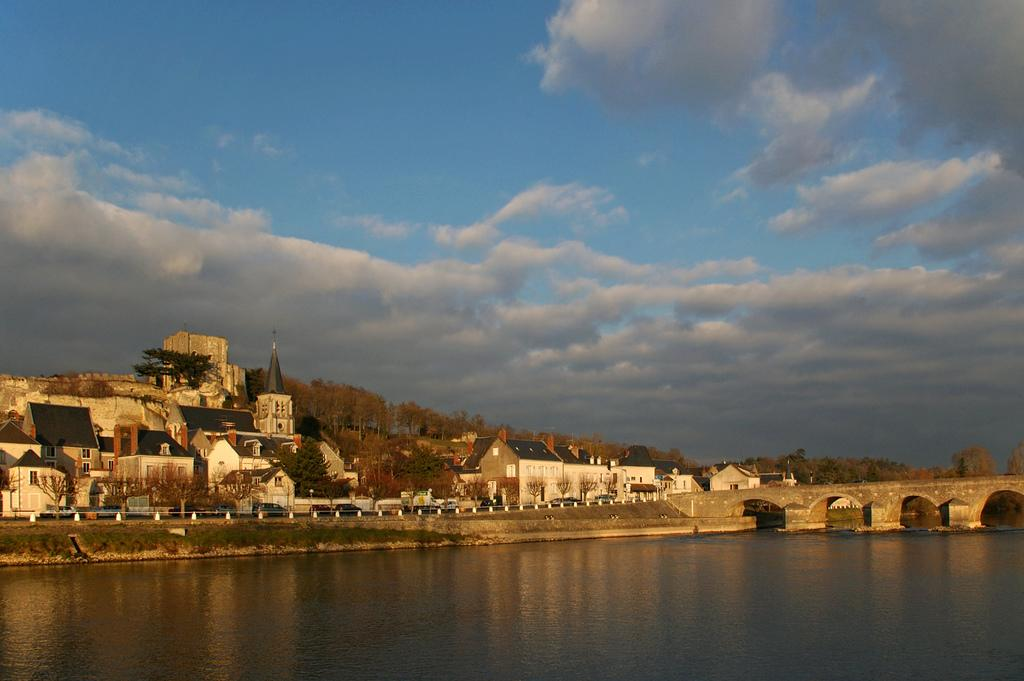What type of structures are present in the image? There are buildings in the image. What natural elements can be seen in the image? There are trees and a lake in the image. Where is the bridge located in the image? The bridge is on the right side of the image. What is the condition of the sky in the image? The sky is cloudy in the image. What language is spoken by the tail in the image? There is no tail present in the image, and therefore no language can be spoken by it. 